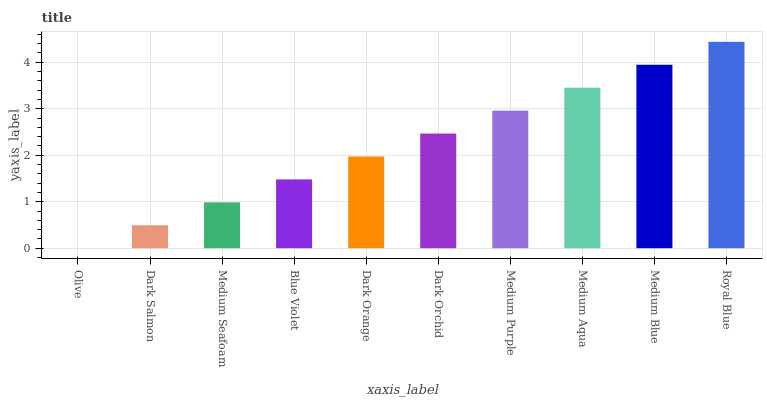Is Olive the minimum?
Answer yes or no. Yes. Is Royal Blue the maximum?
Answer yes or no. Yes. Is Dark Salmon the minimum?
Answer yes or no. No. Is Dark Salmon the maximum?
Answer yes or no. No. Is Dark Salmon greater than Olive?
Answer yes or no. Yes. Is Olive less than Dark Salmon?
Answer yes or no. Yes. Is Olive greater than Dark Salmon?
Answer yes or no. No. Is Dark Salmon less than Olive?
Answer yes or no. No. Is Dark Orchid the high median?
Answer yes or no. Yes. Is Dark Orange the low median?
Answer yes or no. Yes. Is Medium Purple the high median?
Answer yes or no. No. Is Blue Violet the low median?
Answer yes or no. No. 